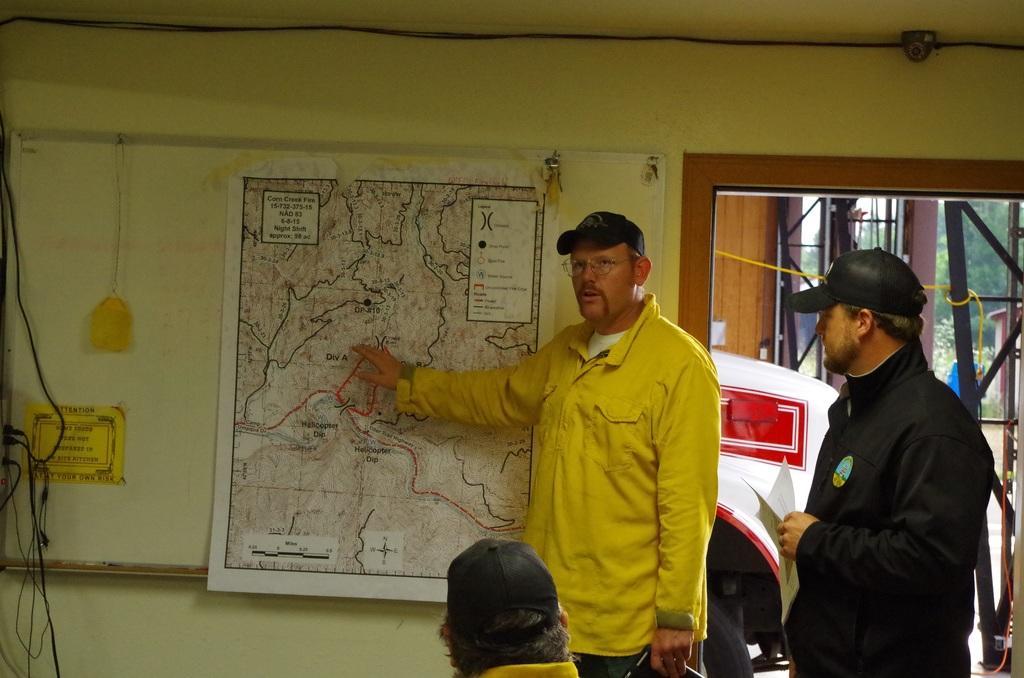How would you summarize this image in a sentence or two? In this image, we can see people wearing coats and caps and one of them is wearing glasses. In the background, we can see a man, a poster and a board on the wall and we can see some cables and a cctv camera and there is a window and some rods. 